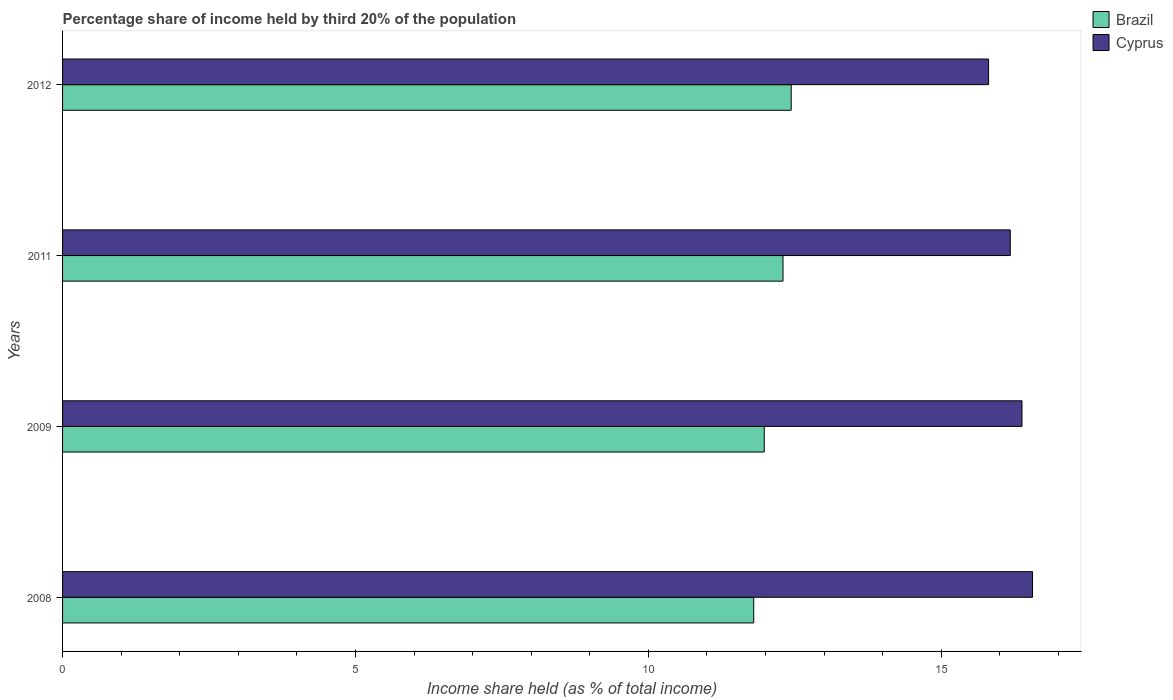How many different coloured bars are there?
Offer a very short reply. 2. Are the number of bars on each tick of the Y-axis equal?
Offer a terse response. Yes. How many bars are there on the 4th tick from the top?
Ensure brevity in your answer.  2. What is the share of income held by third 20% of the population in Brazil in 2009?
Keep it short and to the point. 11.98. Across all years, what is the maximum share of income held by third 20% of the population in Brazil?
Ensure brevity in your answer.  12.44. In which year was the share of income held by third 20% of the population in Cyprus maximum?
Offer a very short reply. 2008. What is the total share of income held by third 20% of the population in Cyprus in the graph?
Your answer should be compact. 64.93. What is the difference between the share of income held by third 20% of the population in Cyprus in 2008 and that in 2009?
Offer a terse response. 0.18. What is the difference between the share of income held by third 20% of the population in Cyprus in 2011 and the share of income held by third 20% of the population in Brazil in 2008?
Make the answer very short. 4.38. What is the average share of income held by third 20% of the population in Cyprus per year?
Your answer should be compact. 16.23. In the year 2011, what is the difference between the share of income held by third 20% of the population in Cyprus and share of income held by third 20% of the population in Brazil?
Provide a succinct answer. 3.88. In how many years, is the share of income held by third 20% of the population in Cyprus greater than 5 %?
Keep it short and to the point. 4. What is the ratio of the share of income held by third 20% of the population in Brazil in 2009 to that in 2011?
Your response must be concise. 0.97. What is the difference between the highest and the second highest share of income held by third 20% of the population in Brazil?
Provide a short and direct response. 0.14. What is the difference between the highest and the lowest share of income held by third 20% of the population in Cyprus?
Offer a terse response. 0.75. In how many years, is the share of income held by third 20% of the population in Brazil greater than the average share of income held by third 20% of the population in Brazil taken over all years?
Your response must be concise. 2. What does the 1st bar from the top in 2012 represents?
Provide a succinct answer. Cyprus. What does the 2nd bar from the bottom in 2008 represents?
Keep it short and to the point. Cyprus. Are all the bars in the graph horizontal?
Provide a succinct answer. Yes. Does the graph contain any zero values?
Keep it short and to the point. No. How many legend labels are there?
Your response must be concise. 2. How are the legend labels stacked?
Offer a very short reply. Vertical. What is the title of the graph?
Your response must be concise. Percentage share of income held by third 20% of the population. Does "Tanzania" appear as one of the legend labels in the graph?
Provide a succinct answer. No. What is the label or title of the X-axis?
Your response must be concise. Income share held (as % of total income). What is the Income share held (as % of total income) of Cyprus in 2008?
Your answer should be very brief. 16.56. What is the Income share held (as % of total income) of Brazil in 2009?
Offer a very short reply. 11.98. What is the Income share held (as % of total income) in Cyprus in 2009?
Your answer should be compact. 16.38. What is the Income share held (as % of total income) of Cyprus in 2011?
Your response must be concise. 16.18. What is the Income share held (as % of total income) of Brazil in 2012?
Your answer should be very brief. 12.44. What is the Income share held (as % of total income) in Cyprus in 2012?
Make the answer very short. 15.81. Across all years, what is the maximum Income share held (as % of total income) in Brazil?
Ensure brevity in your answer.  12.44. Across all years, what is the maximum Income share held (as % of total income) of Cyprus?
Offer a terse response. 16.56. Across all years, what is the minimum Income share held (as % of total income) of Brazil?
Your answer should be compact. 11.8. Across all years, what is the minimum Income share held (as % of total income) in Cyprus?
Make the answer very short. 15.81. What is the total Income share held (as % of total income) in Brazil in the graph?
Keep it short and to the point. 48.52. What is the total Income share held (as % of total income) in Cyprus in the graph?
Give a very brief answer. 64.93. What is the difference between the Income share held (as % of total income) of Brazil in 2008 and that in 2009?
Ensure brevity in your answer.  -0.18. What is the difference between the Income share held (as % of total income) in Cyprus in 2008 and that in 2009?
Your response must be concise. 0.18. What is the difference between the Income share held (as % of total income) in Cyprus in 2008 and that in 2011?
Make the answer very short. 0.38. What is the difference between the Income share held (as % of total income) of Brazil in 2008 and that in 2012?
Ensure brevity in your answer.  -0.64. What is the difference between the Income share held (as % of total income) of Brazil in 2009 and that in 2011?
Give a very brief answer. -0.32. What is the difference between the Income share held (as % of total income) in Brazil in 2009 and that in 2012?
Your response must be concise. -0.46. What is the difference between the Income share held (as % of total income) of Cyprus in 2009 and that in 2012?
Your response must be concise. 0.57. What is the difference between the Income share held (as % of total income) in Brazil in 2011 and that in 2012?
Provide a succinct answer. -0.14. What is the difference between the Income share held (as % of total income) of Cyprus in 2011 and that in 2012?
Offer a terse response. 0.37. What is the difference between the Income share held (as % of total income) in Brazil in 2008 and the Income share held (as % of total income) in Cyprus in 2009?
Your answer should be compact. -4.58. What is the difference between the Income share held (as % of total income) of Brazil in 2008 and the Income share held (as % of total income) of Cyprus in 2011?
Ensure brevity in your answer.  -4.38. What is the difference between the Income share held (as % of total income) of Brazil in 2008 and the Income share held (as % of total income) of Cyprus in 2012?
Your answer should be compact. -4.01. What is the difference between the Income share held (as % of total income) in Brazil in 2009 and the Income share held (as % of total income) in Cyprus in 2012?
Ensure brevity in your answer.  -3.83. What is the difference between the Income share held (as % of total income) of Brazil in 2011 and the Income share held (as % of total income) of Cyprus in 2012?
Your answer should be compact. -3.51. What is the average Income share held (as % of total income) of Brazil per year?
Offer a very short reply. 12.13. What is the average Income share held (as % of total income) in Cyprus per year?
Your answer should be compact. 16.23. In the year 2008, what is the difference between the Income share held (as % of total income) in Brazil and Income share held (as % of total income) in Cyprus?
Give a very brief answer. -4.76. In the year 2009, what is the difference between the Income share held (as % of total income) of Brazil and Income share held (as % of total income) of Cyprus?
Your answer should be very brief. -4.4. In the year 2011, what is the difference between the Income share held (as % of total income) of Brazil and Income share held (as % of total income) of Cyprus?
Your response must be concise. -3.88. In the year 2012, what is the difference between the Income share held (as % of total income) in Brazil and Income share held (as % of total income) in Cyprus?
Give a very brief answer. -3.37. What is the ratio of the Income share held (as % of total income) of Brazil in 2008 to that in 2009?
Offer a terse response. 0.98. What is the ratio of the Income share held (as % of total income) in Cyprus in 2008 to that in 2009?
Give a very brief answer. 1.01. What is the ratio of the Income share held (as % of total income) in Brazil in 2008 to that in 2011?
Offer a terse response. 0.96. What is the ratio of the Income share held (as % of total income) in Cyprus in 2008 to that in 2011?
Your answer should be very brief. 1.02. What is the ratio of the Income share held (as % of total income) in Brazil in 2008 to that in 2012?
Your response must be concise. 0.95. What is the ratio of the Income share held (as % of total income) of Cyprus in 2008 to that in 2012?
Give a very brief answer. 1.05. What is the ratio of the Income share held (as % of total income) of Brazil in 2009 to that in 2011?
Your response must be concise. 0.97. What is the ratio of the Income share held (as % of total income) of Cyprus in 2009 to that in 2011?
Provide a succinct answer. 1.01. What is the ratio of the Income share held (as % of total income) of Brazil in 2009 to that in 2012?
Ensure brevity in your answer.  0.96. What is the ratio of the Income share held (as % of total income) of Cyprus in 2009 to that in 2012?
Your answer should be very brief. 1.04. What is the ratio of the Income share held (as % of total income) of Brazil in 2011 to that in 2012?
Your response must be concise. 0.99. What is the ratio of the Income share held (as % of total income) of Cyprus in 2011 to that in 2012?
Provide a short and direct response. 1.02. What is the difference between the highest and the second highest Income share held (as % of total income) of Brazil?
Your response must be concise. 0.14. What is the difference between the highest and the second highest Income share held (as % of total income) of Cyprus?
Ensure brevity in your answer.  0.18. What is the difference between the highest and the lowest Income share held (as % of total income) in Brazil?
Make the answer very short. 0.64. 